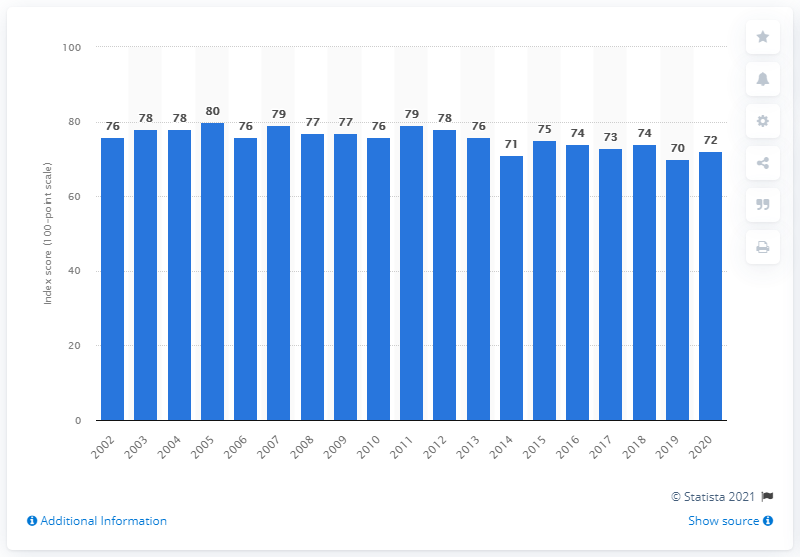Indicate a few pertinent items in this graphic. Yahoo's most recent customer satisfaction score was 72. 